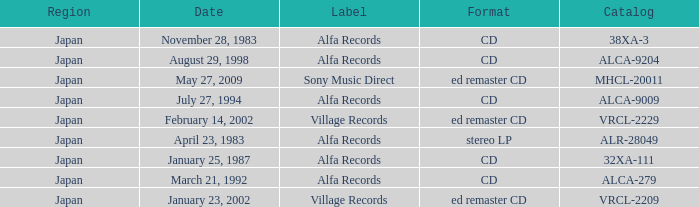What is the format of the date February 14, 2002? Ed remaster cd. 